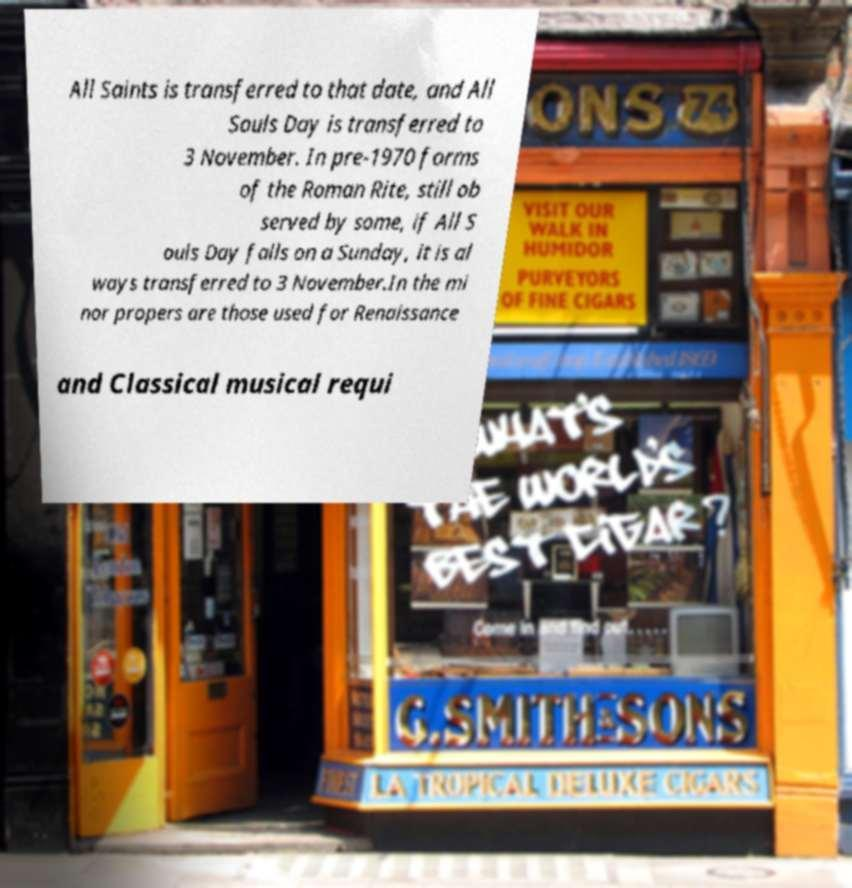I need the written content from this picture converted into text. Can you do that? All Saints is transferred to that date, and All Souls Day is transferred to 3 November. In pre-1970 forms of the Roman Rite, still ob served by some, if All S ouls Day falls on a Sunday, it is al ways transferred to 3 November.In the mi nor propers are those used for Renaissance and Classical musical requi 